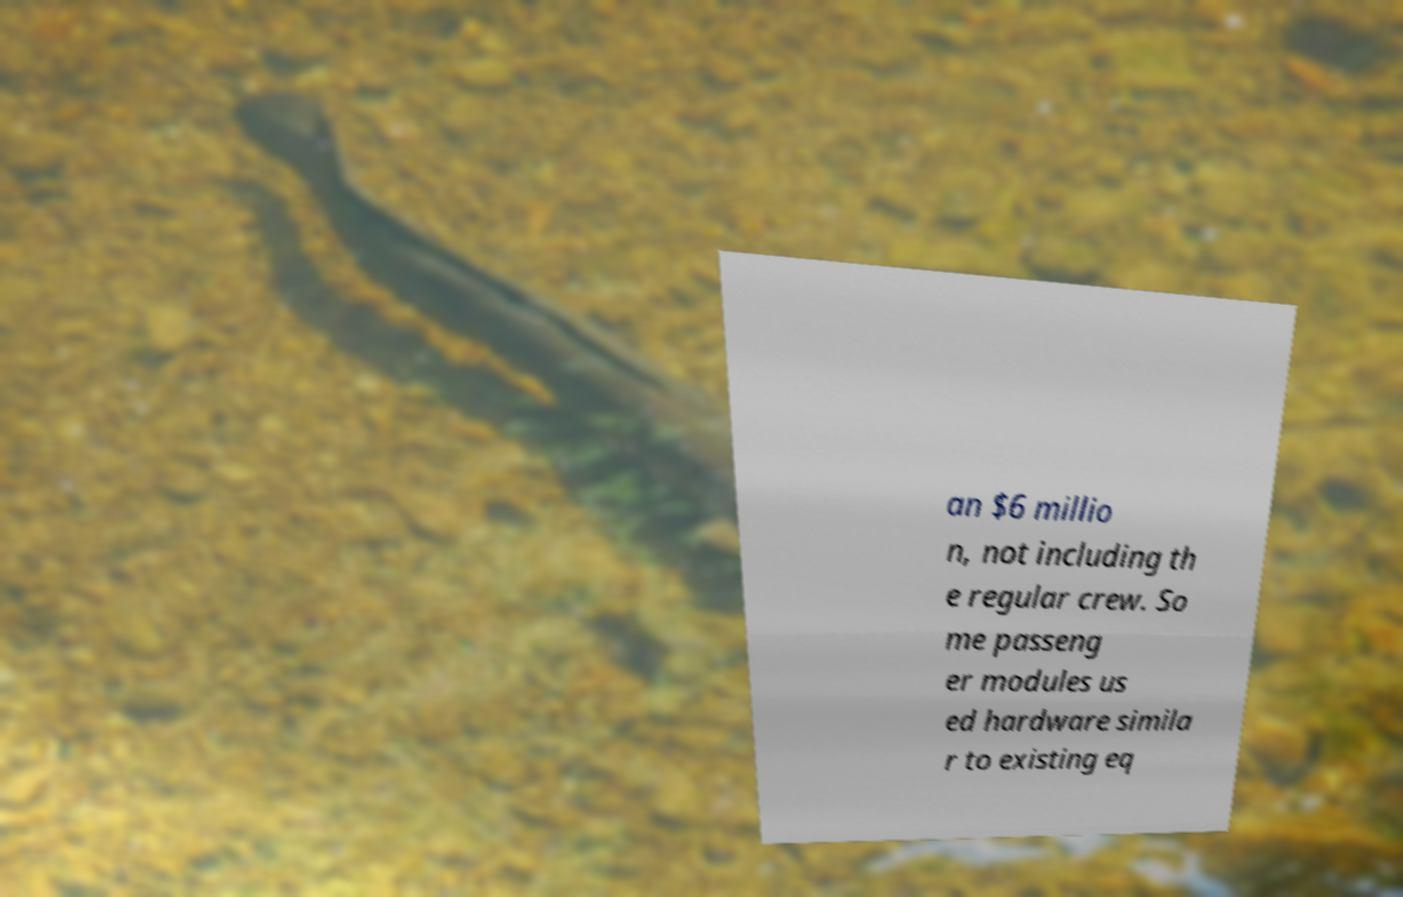Can you accurately transcribe the text from the provided image for me? an $6 millio n, not including th e regular crew. So me passeng er modules us ed hardware simila r to existing eq 